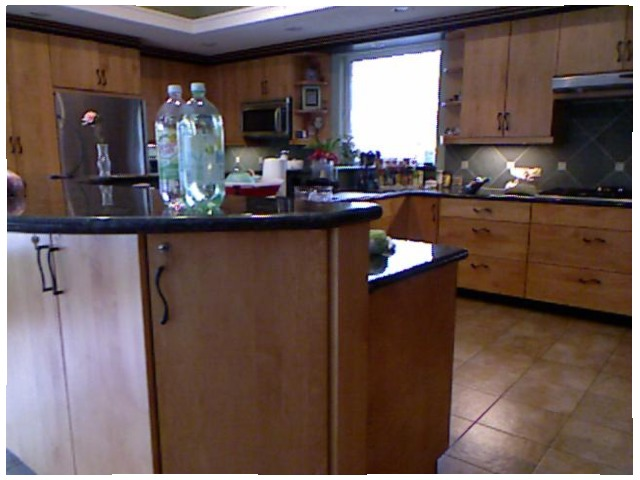<image>
Is there a picture under the water bottle? No. The picture is not positioned under the water bottle. The vertical relationship between these objects is different. Is there a water bottle on the table? Yes. Looking at the image, I can see the water bottle is positioned on top of the table, with the table providing support. Is the flower on the counter? Yes. Looking at the image, I can see the flower is positioned on top of the counter, with the counter providing support. Where is the soda in relation to the door handle? Is it above the door handle? Yes. The soda is positioned above the door handle in the vertical space, higher up in the scene. Is the soda to the right of the microwave? No. The soda is not to the right of the microwave. The horizontal positioning shows a different relationship. 